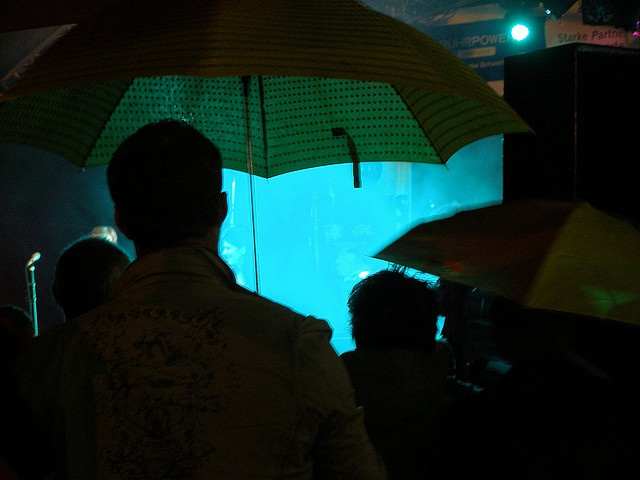Describe the objects in this image and their specific colors. I can see people in black, teal, darkgreen, and darkblue tones, umbrella in black, darkgreen, teal, and cyan tones, umbrella in black, teal, and darkgreen tones, people in black, cyan, and teal tones, and people in black tones in this image. 